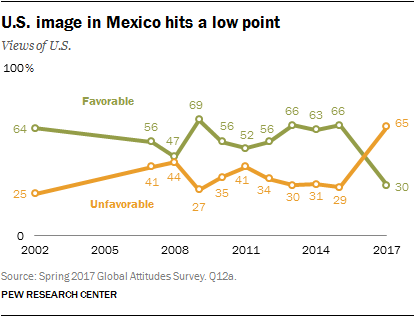Point out several critical features in this image. The favorable number for the year 2014 is 63. In 2017, the term "unfavorable" referred to conditions or circumstances that were not favorable or positive, while "favorable" referred to conditions or circumstances that were favorable or positive. 